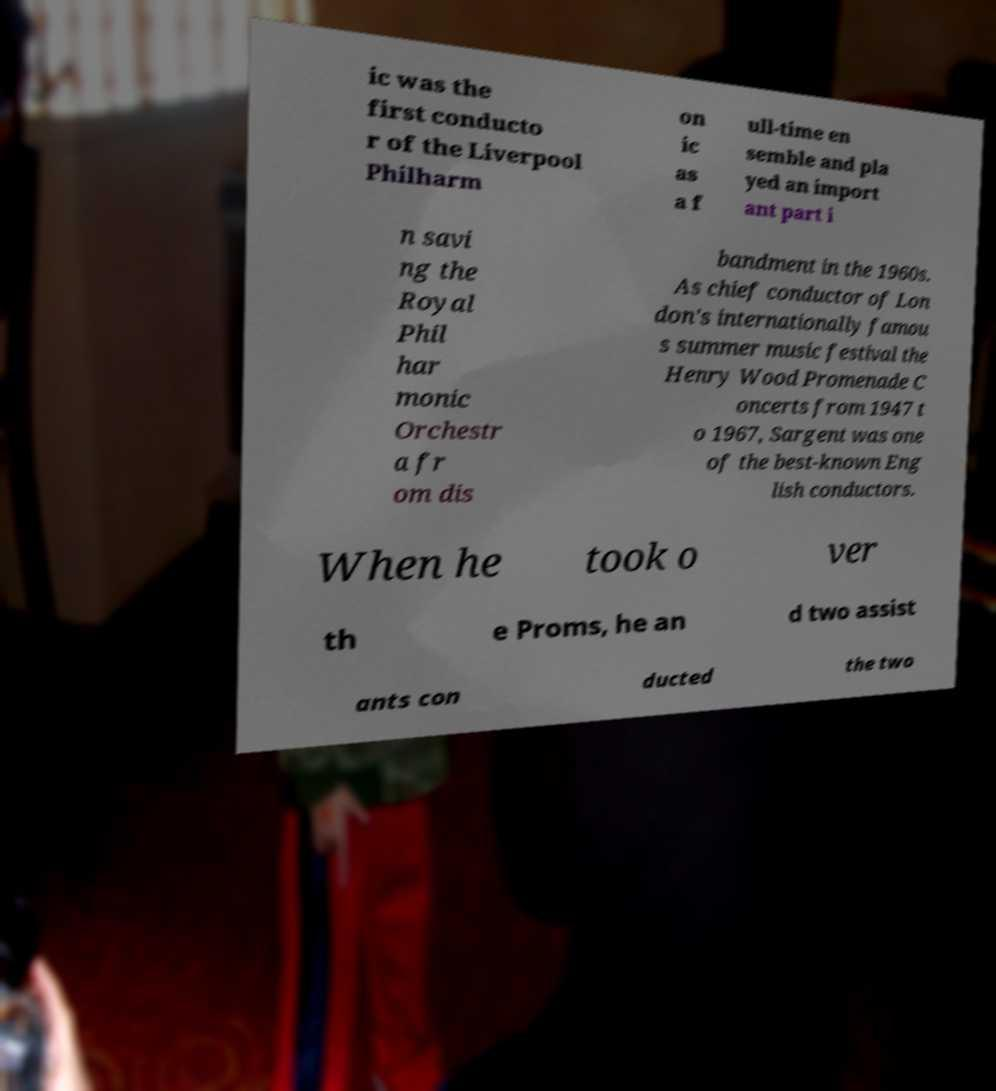I need the written content from this picture converted into text. Can you do that? ic was the first conducto r of the Liverpool Philharm on ic as a f ull-time en semble and pla yed an import ant part i n savi ng the Royal Phil har monic Orchestr a fr om dis bandment in the 1960s. As chief conductor of Lon don's internationally famou s summer music festival the Henry Wood Promenade C oncerts from 1947 t o 1967, Sargent was one of the best-known Eng lish conductors. When he took o ver th e Proms, he an d two assist ants con ducted the two 